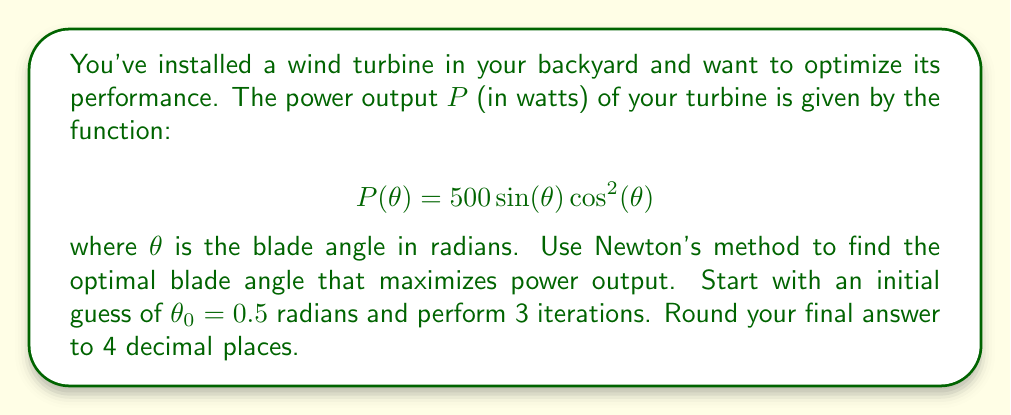Help me with this question. To find the maximum power output, we need to find the value of $\theta$ where $P'(\theta) = 0$. Let's apply Newton's method:

1) First, calculate $P'(\theta)$ and $P''(\theta)$:
   $$P'(\theta) = 500(\cos^3(\theta) - 2\sin^2(\theta)\cos(\theta))$$
   $$P''(\theta) = 500(-3\sin(\theta)\cos^2(\theta) - 2\sin^3(\theta) - 4\sin(\theta)\cos^2(\theta))$$

2) Newton's method formula:
   $$\theta_{n+1} = \theta_n - \frac{P'(\theta_n)}{P''(\theta_n)}$$

3) Iteration 1:
   $\theta_0 = 0.5$
   $P'(0.5) = 500(0.9297 - 0.3864) = 271.6434$
   $P''(0.5) = 500(-1.2715 - 0.0874 - 1.6954) = -1527.1657$
   $$\theta_1 = 0.5 - \frac{271.6434}{-1527.1657} = 0.6778$$

4) Iteration 2:
   $P'(0.6778) = 500(0.7925 - 0.6218) = 85.3614$
   $P''(0.6778) = 500(-1.9090 - 0.2161 - 2.5453) = -2335.1735$
   $$\theta_2 = 0.6778 - \frac{85.3614}{-2335.1735} = 0.7144$$

5) Iteration 3:
   $P'(0.7144) = 500(0.7344 - 0.6981) = 18.1509$
   $P''(0.7144) = 500(-2.0561 - 0.2589 - 2.7415) = -2528.2500$
   $$\theta_3 = 0.7144 - \frac{18.1509}{-2528.2500} = 0.7216$$

6) Round the final result to 4 decimal places: 0.7216 radians
Answer: 0.7216 radians 